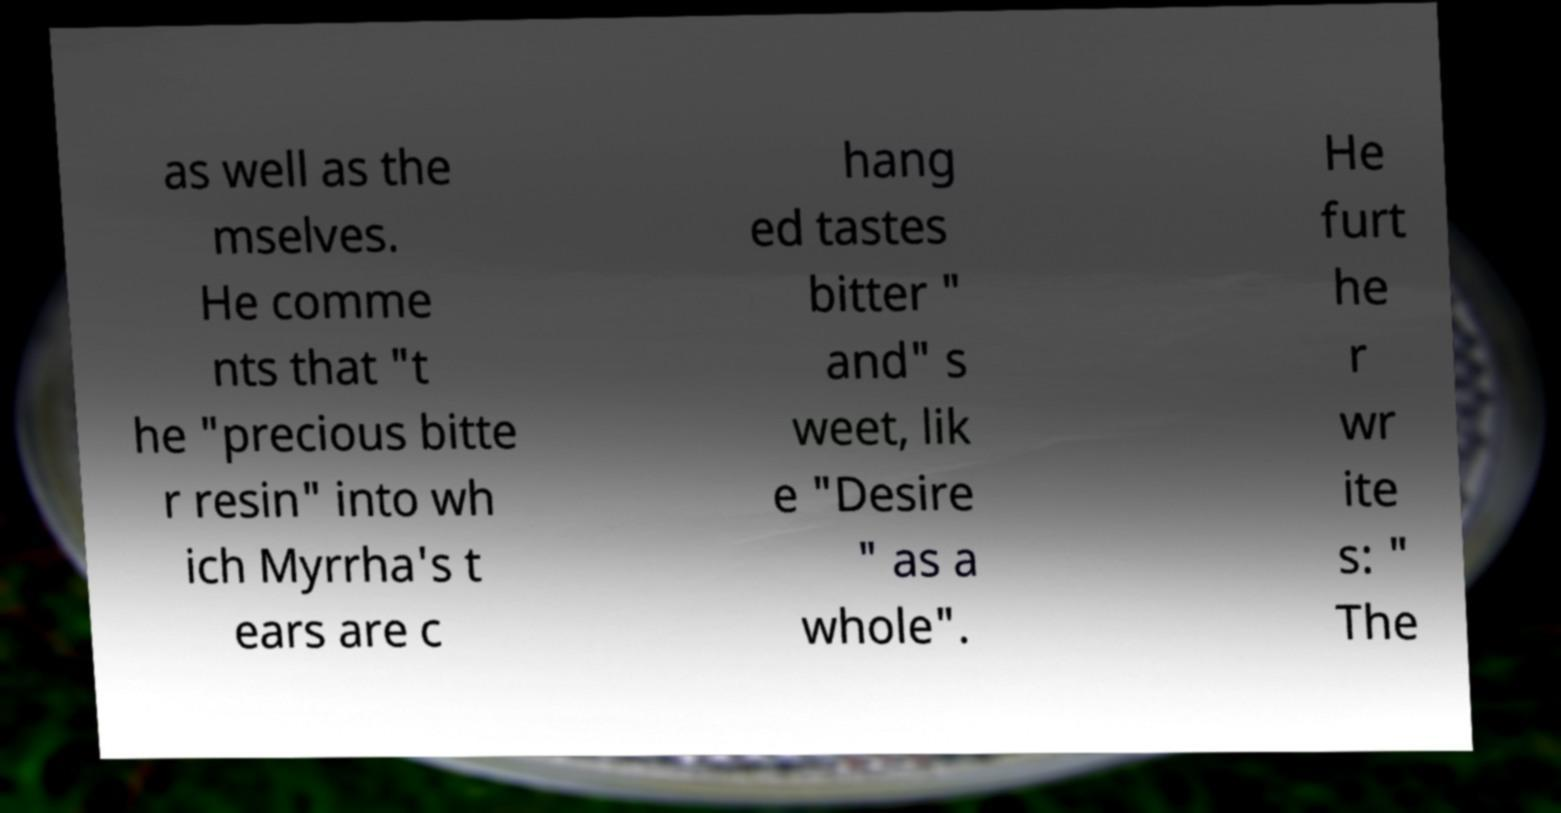Can you accurately transcribe the text from the provided image for me? as well as the mselves. He comme nts that "t he "precious bitte r resin" into wh ich Myrrha's t ears are c hang ed tastes bitter " and" s weet, lik e "Desire " as a whole". He furt he r wr ite s: " The 